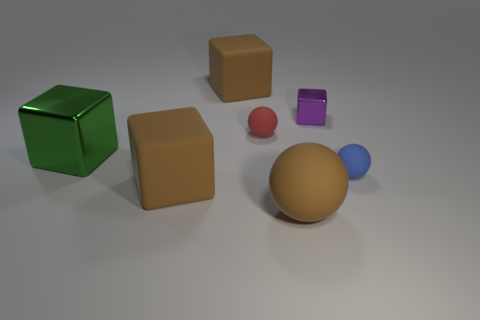Add 1 blue matte spheres. How many objects exist? 8 Subtract all red rubber spheres. How many spheres are left? 2 Subtract all brown cubes. How many cubes are left? 2 Subtract 0 red blocks. How many objects are left? 7 Subtract all cubes. How many objects are left? 3 Subtract 2 balls. How many balls are left? 1 Subtract all purple balls. Subtract all purple cubes. How many balls are left? 3 Subtract all gray balls. How many purple blocks are left? 1 Subtract all small red balls. Subtract all tiny blue balls. How many objects are left? 5 Add 4 red rubber balls. How many red rubber balls are left? 5 